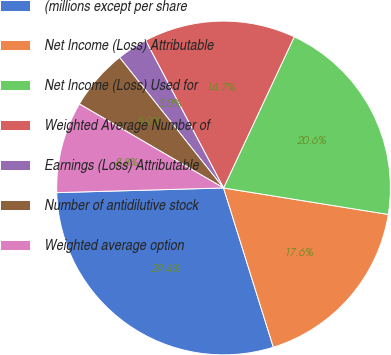Convert chart. <chart><loc_0><loc_0><loc_500><loc_500><pie_chart><fcel>(millions except per share<fcel>Net Income (Loss) Attributable<fcel>Net Income (Loss) Used for<fcel>Weighted Average Number of<fcel>Earnings (Loss) Attributable<fcel>Number of antidilutive stock<fcel>Weighted average option<nl><fcel>29.38%<fcel>17.64%<fcel>20.57%<fcel>14.7%<fcel>2.97%<fcel>5.9%<fcel>8.84%<nl></chart> 